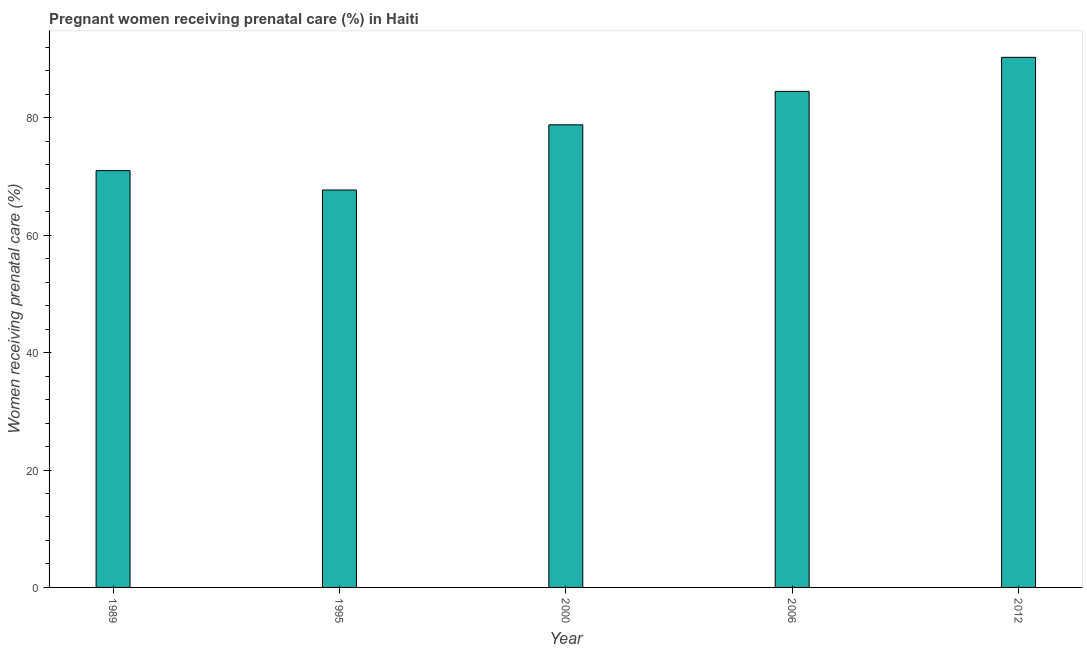Does the graph contain any zero values?
Your answer should be very brief. No. Does the graph contain grids?
Provide a succinct answer. No. What is the title of the graph?
Offer a very short reply. Pregnant women receiving prenatal care (%) in Haiti. What is the label or title of the Y-axis?
Keep it short and to the point. Women receiving prenatal care (%). What is the percentage of pregnant women receiving prenatal care in 1995?
Keep it short and to the point. 67.7. Across all years, what is the maximum percentage of pregnant women receiving prenatal care?
Your answer should be compact. 90.3. Across all years, what is the minimum percentage of pregnant women receiving prenatal care?
Offer a very short reply. 67.7. In which year was the percentage of pregnant women receiving prenatal care maximum?
Give a very brief answer. 2012. In which year was the percentage of pregnant women receiving prenatal care minimum?
Offer a terse response. 1995. What is the sum of the percentage of pregnant women receiving prenatal care?
Offer a terse response. 392.3. What is the difference between the percentage of pregnant women receiving prenatal care in 2000 and 2012?
Ensure brevity in your answer.  -11.5. What is the average percentage of pregnant women receiving prenatal care per year?
Make the answer very short. 78.46. What is the median percentage of pregnant women receiving prenatal care?
Ensure brevity in your answer.  78.8. In how many years, is the percentage of pregnant women receiving prenatal care greater than 40 %?
Offer a terse response. 5. What is the ratio of the percentage of pregnant women receiving prenatal care in 1989 to that in 1995?
Give a very brief answer. 1.05. Is the difference between the percentage of pregnant women receiving prenatal care in 1995 and 2012 greater than the difference between any two years?
Give a very brief answer. Yes. What is the difference between the highest and the second highest percentage of pregnant women receiving prenatal care?
Your response must be concise. 5.8. Is the sum of the percentage of pregnant women receiving prenatal care in 1995 and 2012 greater than the maximum percentage of pregnant women receiving prenatal care across all years?
Your response must be concise. Yes. What is the difference between the highest and the lowest percentage of pregnant women receiving prenatal care?
Make the answer very short. 22.6. Are all the bars in the graph horizontal?
Make the answer very short. No. What is the difference between two consecutive major ticks on the Y-axis?
Your answer should be very brief. 20. What is the Women receiving prenatal care (%) of 1995?
Provide a short and direct response. 67.7. What is the Women receiving prenatal care (%) in 2000?
Your answer should be very brief. 78.8. What is the Women receiving prenatal care (%) of 2006?
Your answer should be very brief. 84.5. What is the Women receiving prenatal care (%) in 2012?
Keep it short and to the point. 90.3. What is the difference between the Women receiving prenatal care (%) in 1989 and 1995?
Your response must be concise. 3.3. What is the difference between the Women receiving prenatal care (%) in 1989 and 2000?
Ensure brevity in your answer.  -7.8. What is the difference between the Women receiving prenatal care (%) in 1989 and 2006?
Make the answer very short. -13.5. What is the difference between the Women receiving prenatal care (%) in 1989 and 2012?
Provide a succinct answer. -19.3. What is the difference between the Women receiving prenatal care (%) in 1995 and 2006?
Make the answer very short. -16.8. What is the difference between the Women receiving prenatal care (%) in 1995 and 2012?
Provide a succinct answer. -22.6. What is the difference between the Women receiving prenatal care (%) in 2000 and 2012?
Provide a short and direct response. -11.5. What is the ratio of the Women receiving prenatal care (%) in 1989 to that in 1995?
Keep it short and to the point. 1.05. What is the ratio of the Women receiving prenatal care (%) in 1989 to that in 2000?
Offer a very short reply. 0.9. What is the ratio of the Women receiving prenatal care (%) in 1989 to that in 2006?
Make the answer very short. 0.84. What is the ratio of the Women receiving prenatal care (%) in 1989 to that in 2012?
Keep it short and to the point. 0.79. What is the ratio of the Women receiving prenatal care (%) in 1995 to that in 2000?
Your response must be concise. 0.86. What is the ratio of the Women receiving prenatal care (%) in 1995 to that in 2006?
Ensure brevity in your answer.  0.8. What is the ratio of the Women receiving prenatal care (%) in 2000 to that in 2006?
Provide a short and direct response. 0.93. What is the ratio of the Women receiving prenatal care (%) in 2000 to that in 2012?
Give a very brief answer. 0.87. What is the ratio of the Women receiving prenatal care (%) in 2006 to that in 2012?
Provide a succinct answer. 0.94. 